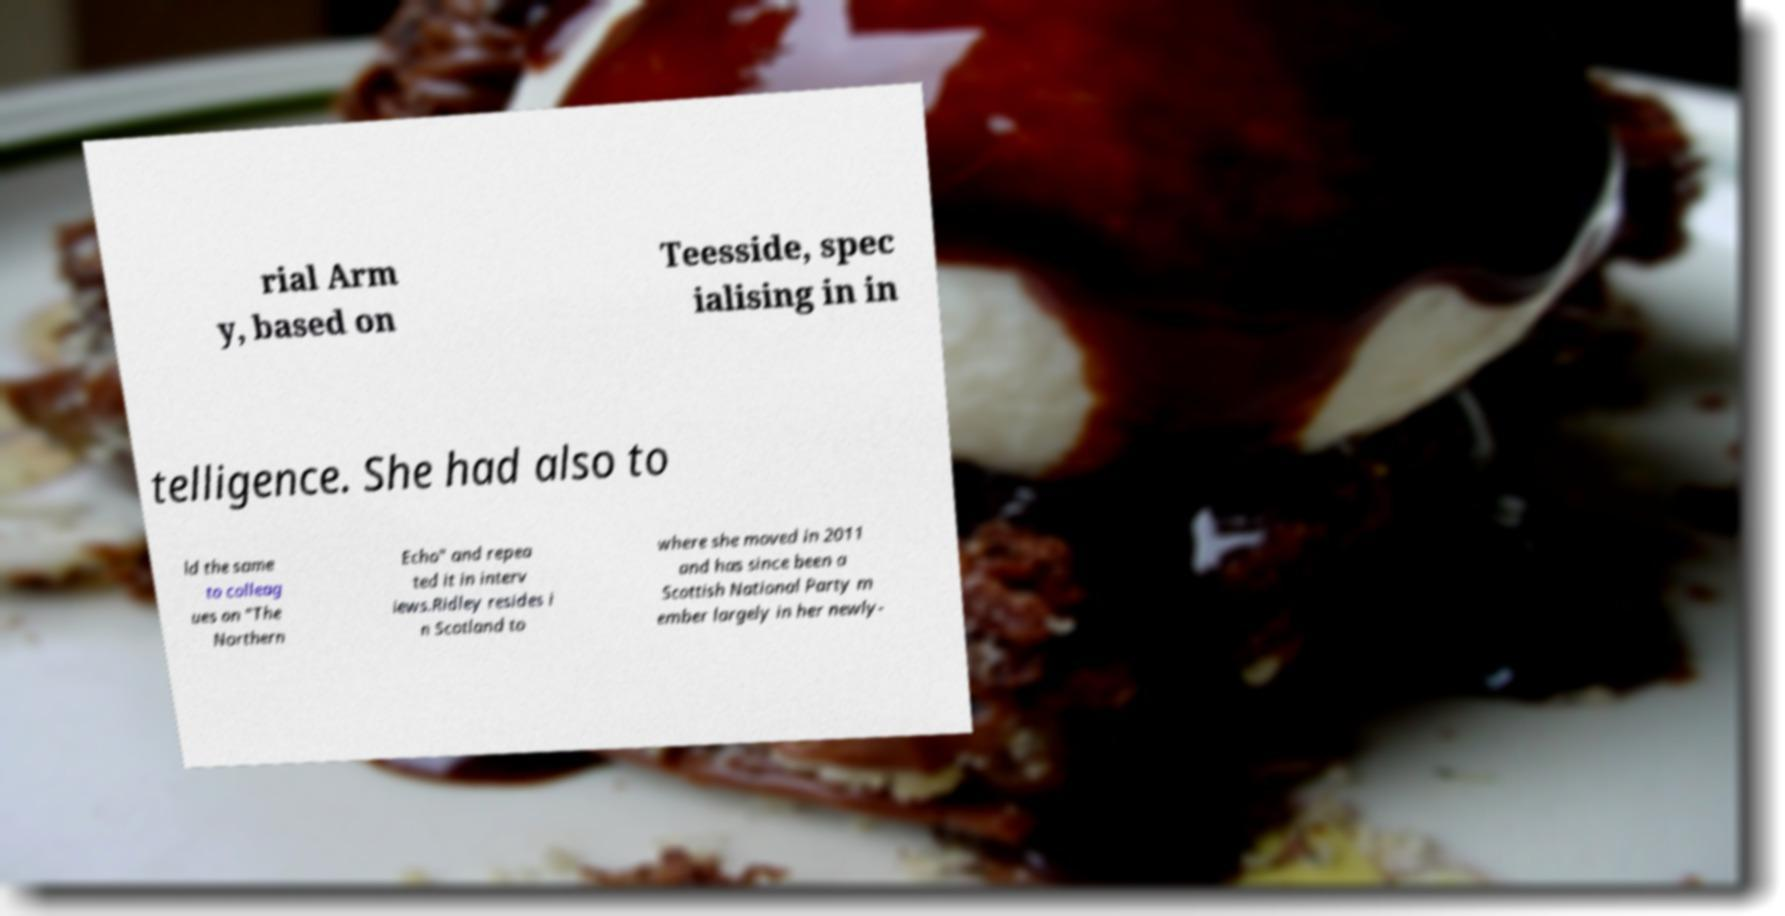Can you accurately transcribe the text from the provided image for me? rial Arm y, based on Teesside, spec ialising in in telligence. She had also to ld the same to colleag ues on "The Northern Echo" and repea ted it in interv iews.Ridley resides i n Scotland to where she moved in 2011 and has since been a Scottish National Party m ember largely in her newly- 